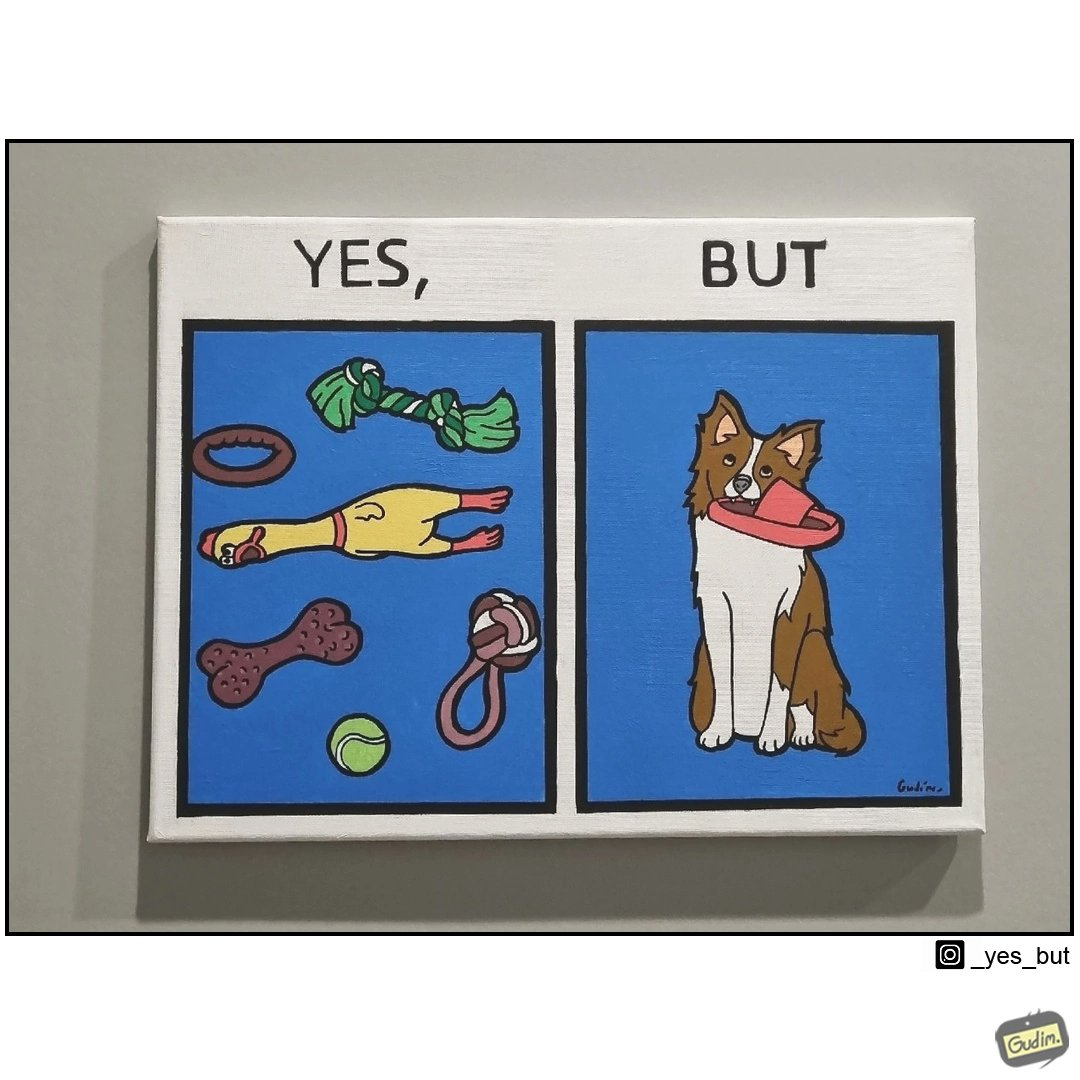Would you classify this image as satirical? Yes, this image is satirical. 